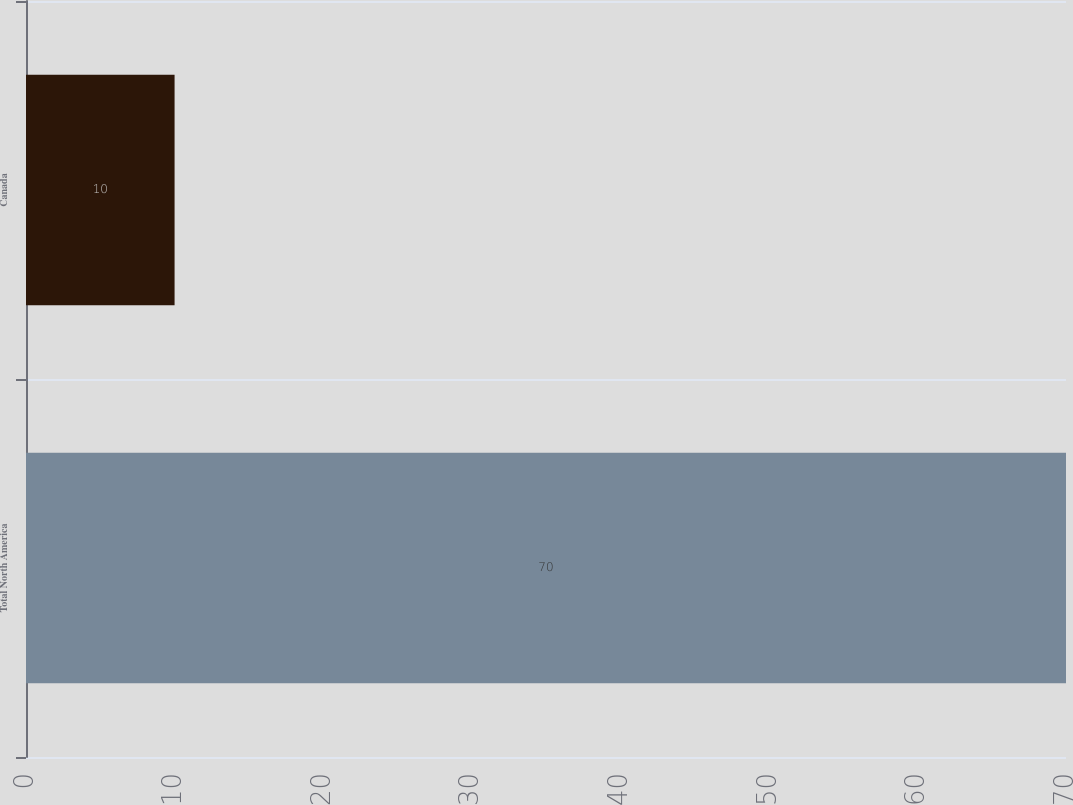Convert chart. <chart><loc_0><loc_0><loc_500><loc_500><bar_chart><fcel>Total North America<fcel>Canada<nl><fcel>70<fcel>10<nl></chart> 